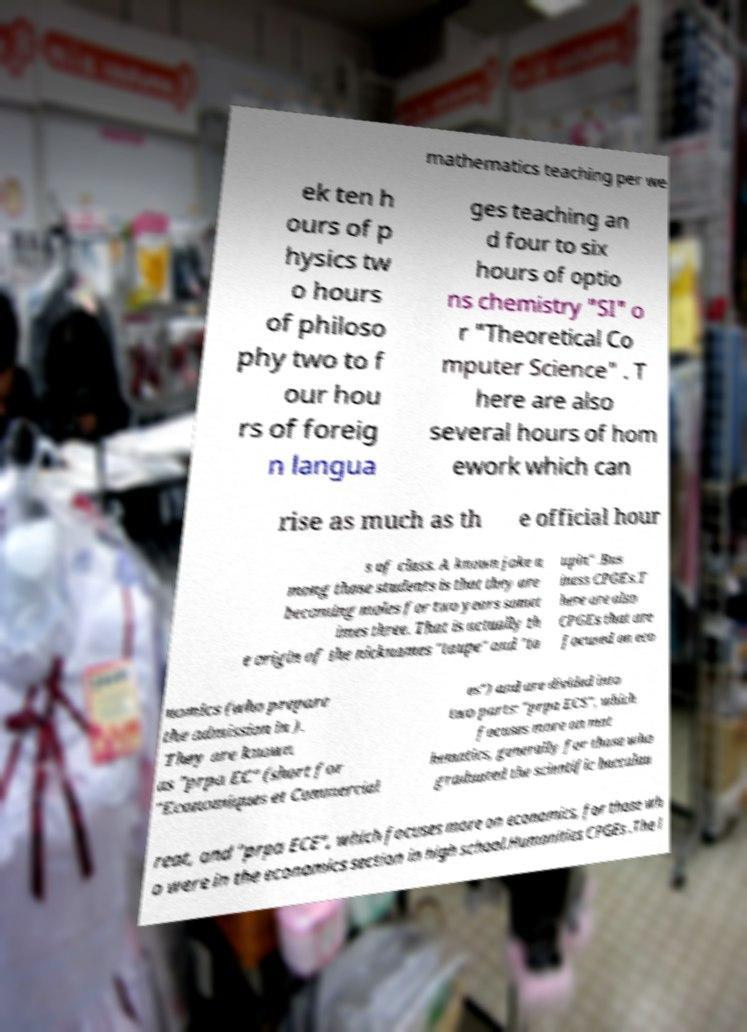Could you assist in decoding the text presented in this image and type it out clearly? mathematics teaching per we ek ten h ours of p hysics tw o hours of philoso phy two to f our hou rs of foreig n langua ges teaching an d four to six hours of optio ns chemistry "SI" o r "Theoretical Co mputer Science" . T here are also several hours of hom ework which can rise as much as th e official hour s of class. A known joke a mong those students is that they are becoming moles for two years somet imes three. That is actually th e origin of the nicknames "taupe" and "ta upin" .Bus iness CPGEs.T here are also CPGEs that are focused on eco nomics (who prepare the admission in ). They are known as "prpa EC" (short for "Economiques et Commercial es") and are divided into two parts: "prpa ECS", which focuses more on mat hematics, generally for those who graduated the scientific baccalau reat, and "prpa ECE", which focuses more on economics, for those wh o were in the economics section in high school.Humanities CPGEs .The l 